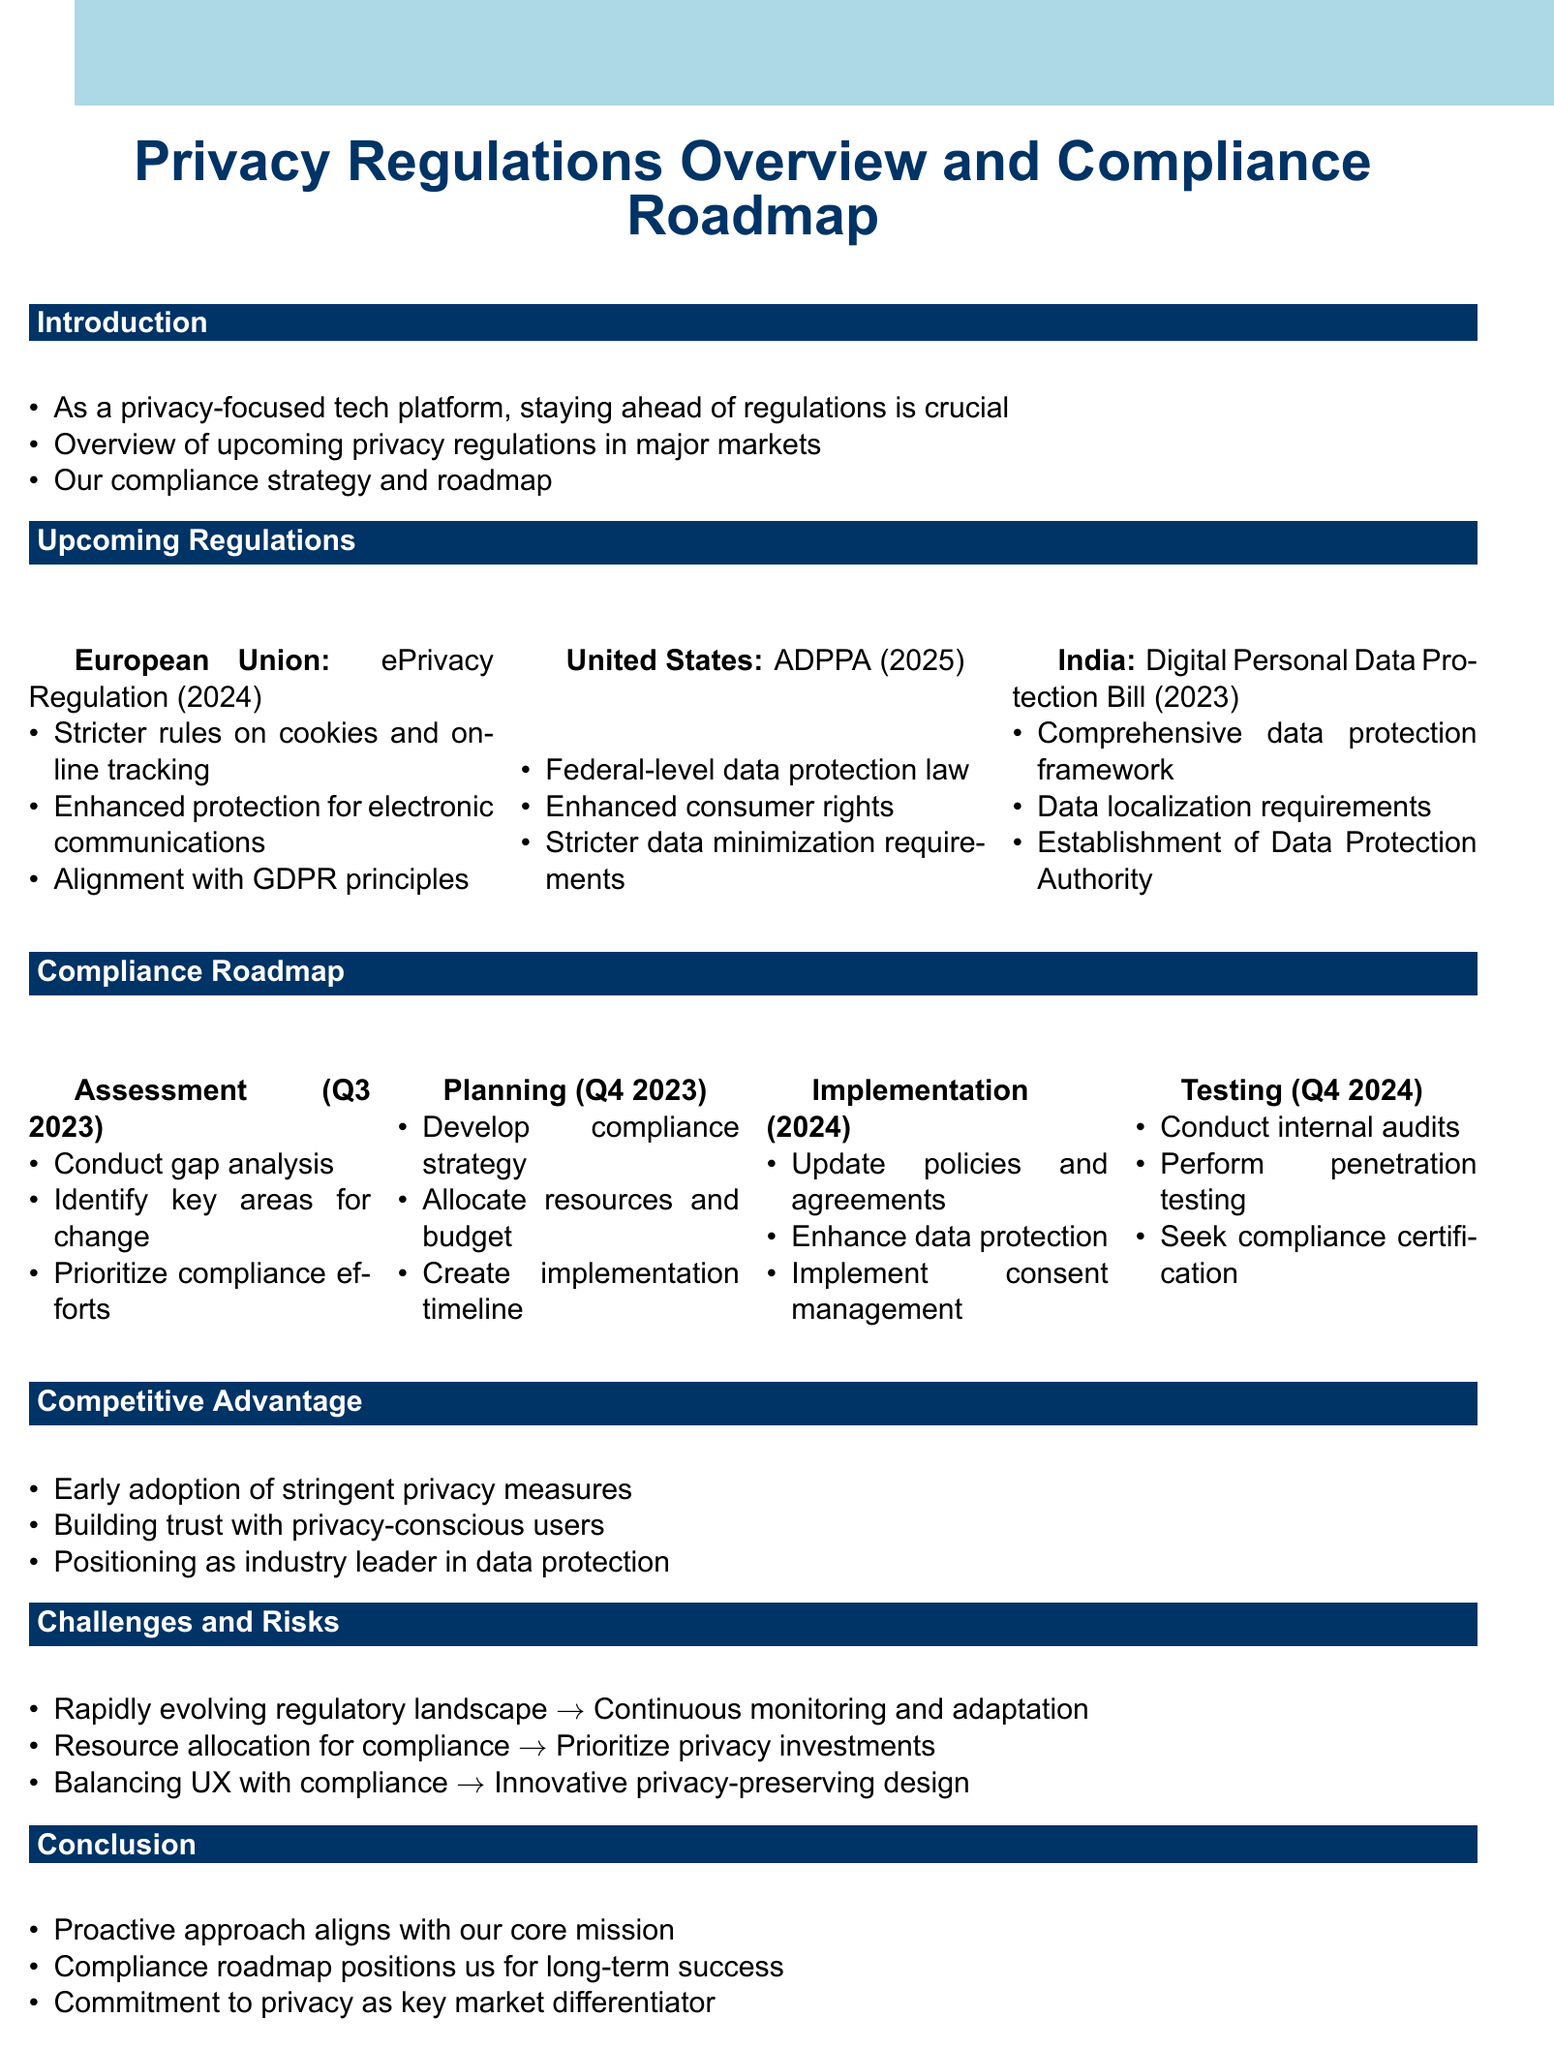What is the title of the memo? The title of the memo is provided at the beginning, explicitly stated in the document.
Answer: Privacy Regulations Overview and Compliance Roadmap What is the expected implementation year for the ePrivacy Regulation? The expected implementation year is outlined in the section that details upcoming regulations, specifically for the European Union.
Answer: 2024 What are the key features of the American Data Privacy and Protection Act? The document lists the key features under the section for upcoming regulations for the United States, providing specific points for the ADPPA.
Answer: Federal-level data protection law, Enhanced consumer rights, Stricter data minimization requirements What phase comes after Assessment in the compliance roadmap? The compliance roadmap outlines phases in a sequential manner, and the phase following Assessment is explicitly mentioned.
Answer: Planning What is the timeline for the Testing and Validation phase? The timeline for each phase is included in the compliance roadmap section, indicating when specific actions will be taken.
Answer: Q4 2024 How does the company plan to mitigate resource allocation challenges for compliance efforts? The challenges and their mitigations are detailed in the document, providing specific strategies for addressing resource allocation issues.
Answer: Prioritize privacy investments as core business strategy What is the core mission of the company as mentioned in the conclusion? The conclusion emphasizes the company's commitment to privacy in alignment with its mission, reflecting its strategic position.
Answer: Proactive approach to privacy regulations What does the company aim to achieve by early adoption of stringent privacy measures? The competitive advantage section addresses the intentions of the company regarding early adoption and how it relates to user perception.
Answer: Building trust with privacy-conscious users 